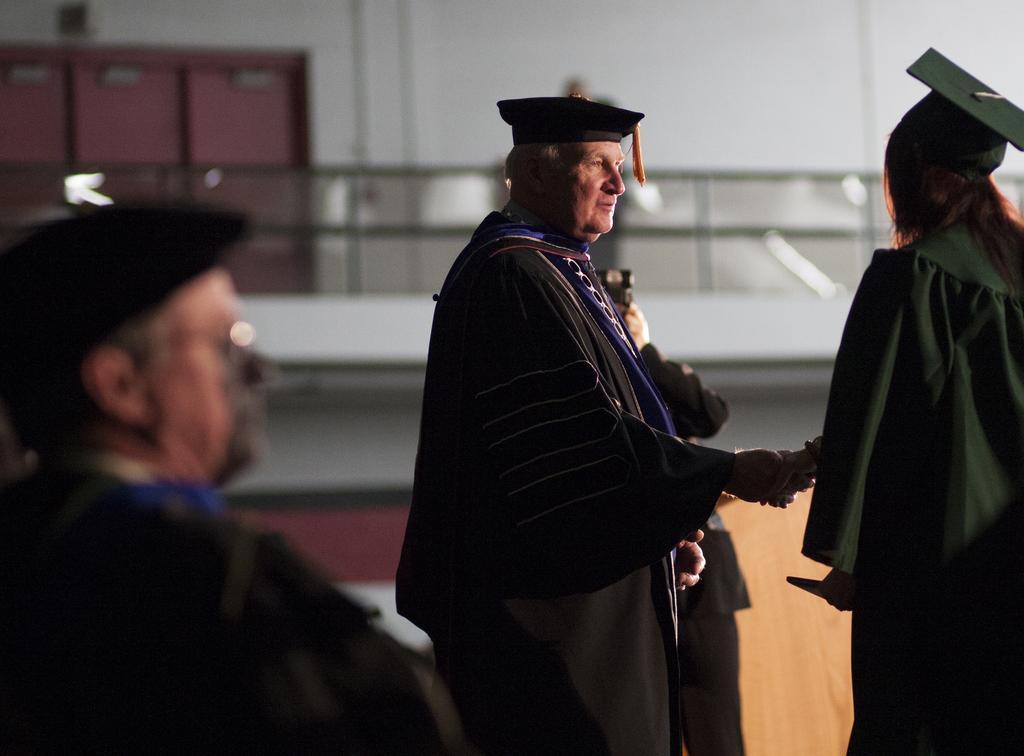Please provide a concise description of this image. In this picture we can see four persons, three persons in the front are wearing hats, a person in the background is holding a camera, in the background there is a wall. 